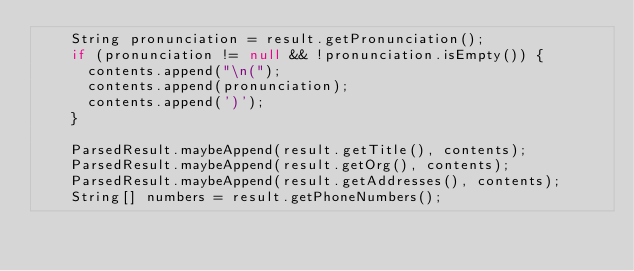Convert code to text. <code><loc_0><loc_0><loc_500><loc_500><_Java_>    String pronunciation = result.getPronunciation();
    if (pronunciation != null && !pronunciation.isEmpty()) {
      contents.append("\n(");
      contents.append(pronunciation);
      contents.append(')');
    }

    ParsedResult.maybeAppend(result.getTitle(), contents);
    ParsedResult.maybeAppend(result.getOrg(), contents);
    ParsedResult.maybeAppend(result.getAddresses(), contents);
    String[] numbers = result.getPhoneNumbers();</code> 